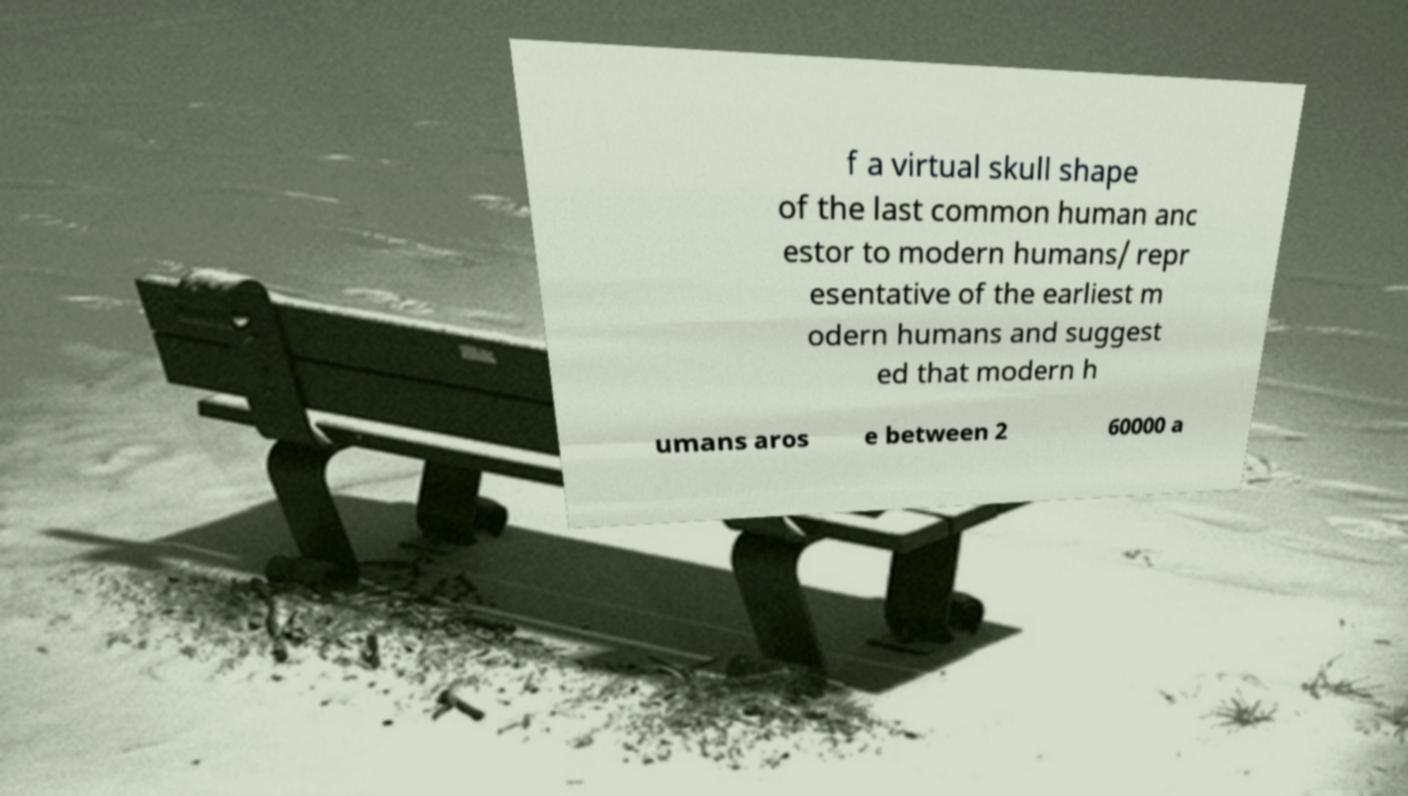Please read and relay the text visible in this image. What does it say? f a virtual skull shape of the last common human anc estor to modern humans/ repr esentative of the earliest m odern humans and suggest ed that modern h umans aros e between 2 60000 a 